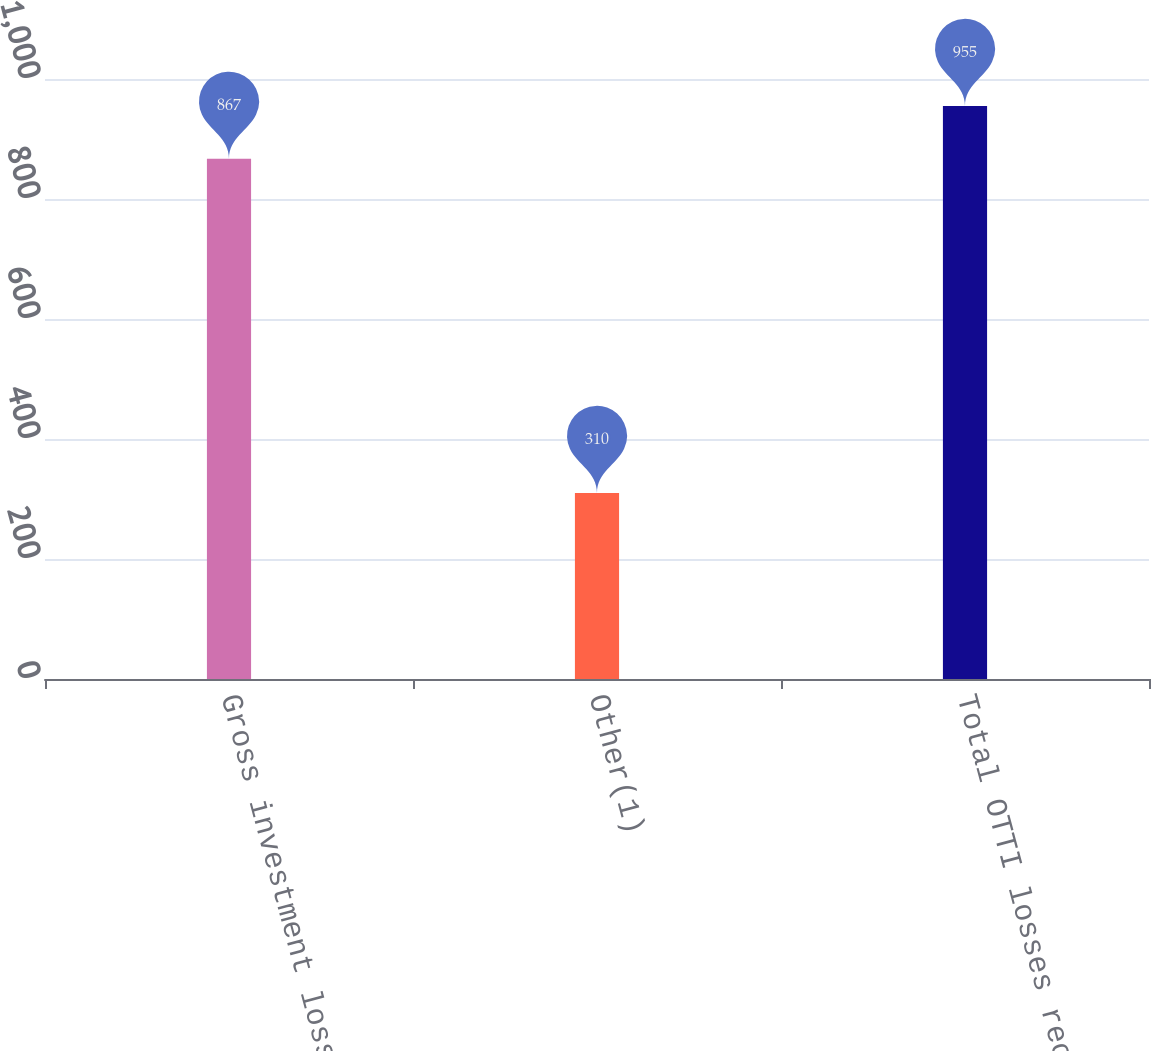Convert chart. <chart><loc_0><loc_0><loc_500><loc_500><bar_chart><fcel>Gross investment losses<fcel>Other(1)<fcel>Total OTTI losses recognized<nl><fcel>867<fcel>310<fcel>955<nl></chart> 